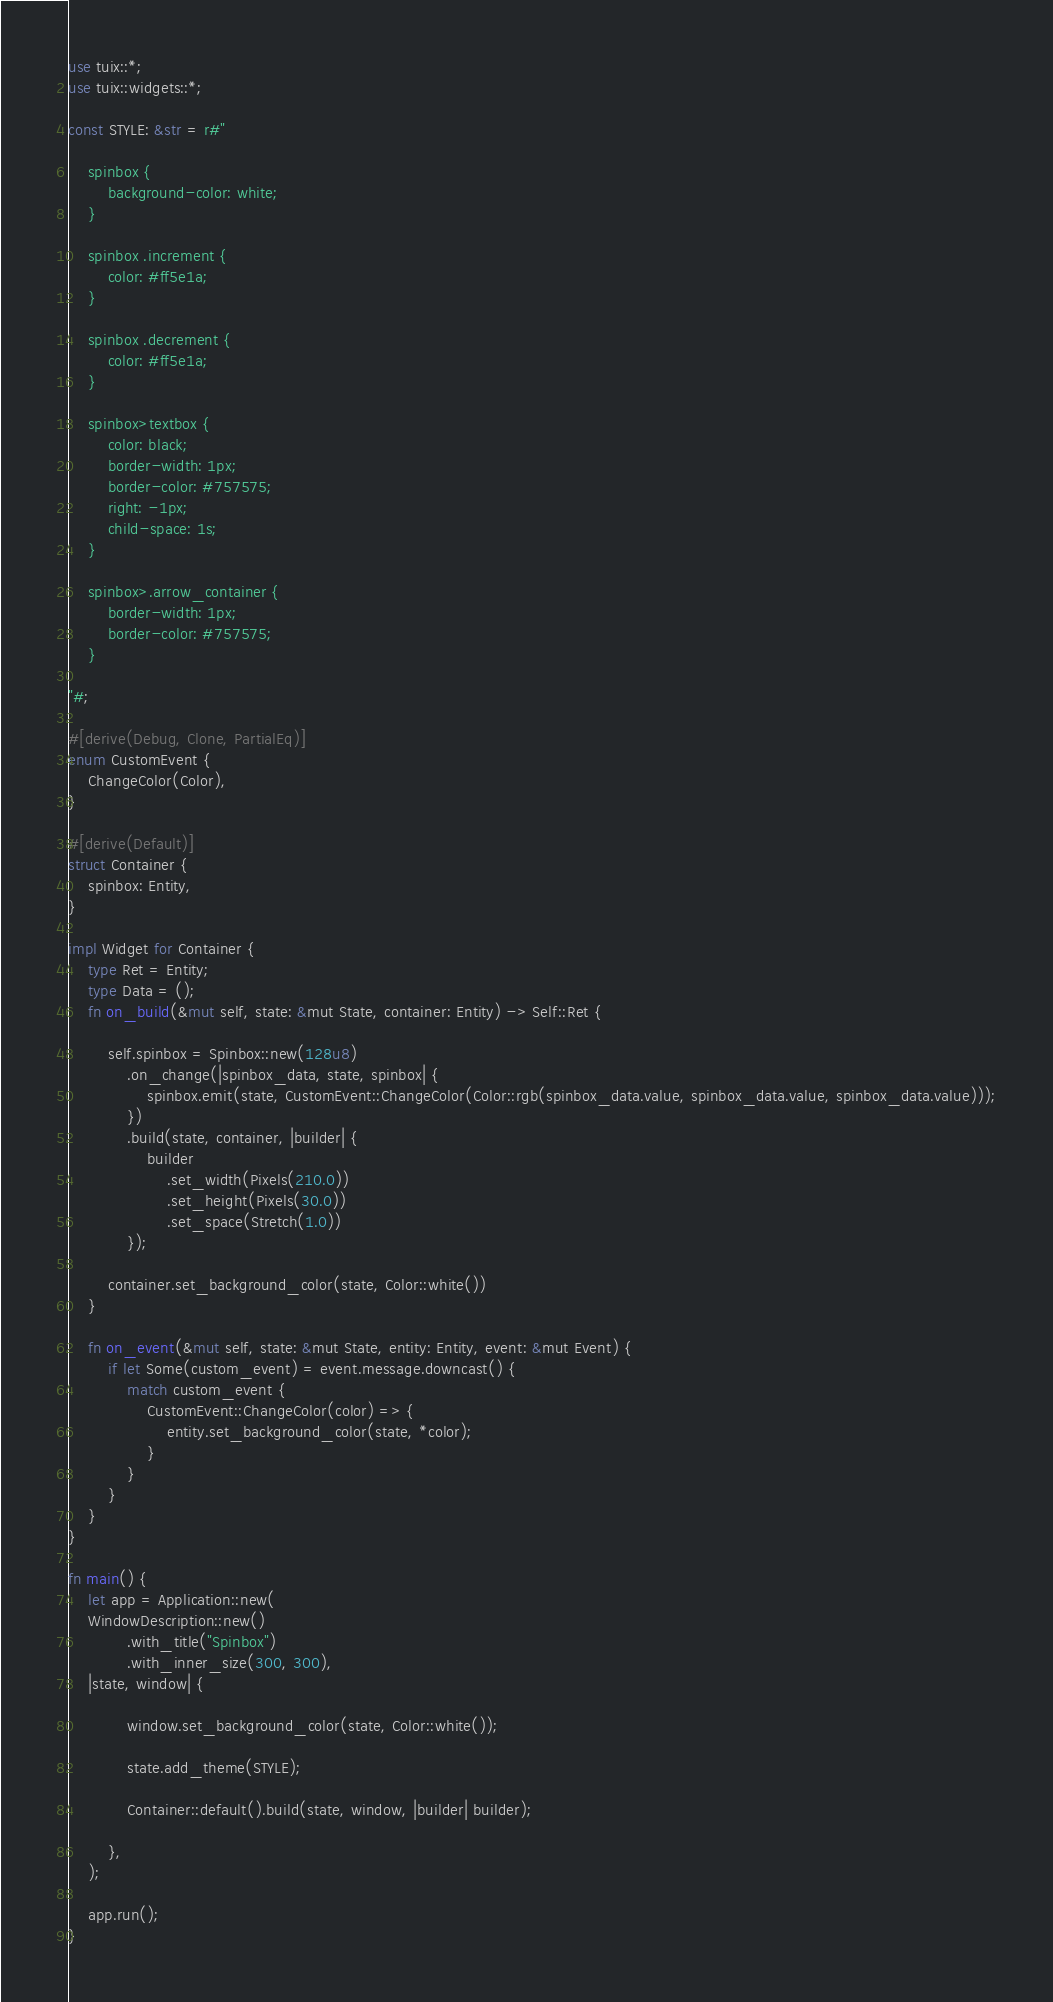<code> <loc_0><loc_0><loc_500><loc_500><_Rust_>use tuix::*;
use tuix::widgets::*;

const STYLE: &str = r#"

    spinbox {
        background-color: white;
    }

    spinbox .increment {
        color: #ff5e1a;
    }

    spinbox .decrement {
        color: #ff5e1a;
    }

    spinbox>textbox {
        color: black;
        border-width: 1px;
        border-color: #757575;
        right: -1px;
        child-space: 1s;
    }

    spinbox>.arrow_container {
        border-width: 1px;
        border-color: #757575;
    }

"#;

#[derive(Debug, Clone, PartialEq)]
enum CustomEvent {
    ChangeColor(Color),
}

#[derive(Default)]
struct Container {
    spinbox: Entity,
}

impl Widget for Container {
    type Ret = Entity;
    type Data = ();
    fn on_build(&mut self, state: &mut State, container: Entity) -> Self::Ret {

        self.spinbox = Spinbox::new(128u8)
            .on_change(|spinbox_data, state, spinbox| {
                spinbox.emit(state, CustomEvent::ChangeColor(Color::rgb(spinbox_data.value, spinbox_data.value, spinbox_data.value)));
            })
            .build(state, container, |builder| {
                builder
                    .set_width(Pixels(210.0))
                    .set_height(Pixels(30.0))
                    .set_space(Stretch(1.0))
            });

        container.set_background_color(state, Color::white())
    }

    fn on_event(&mut self, state: &mut State, entity: Entity, event: &mut Event) {
        if let Some(custom_event) = event.message.downcast() {
            match custom_event {
                CustomEvent::ChangeColor(color) => {
                    entity.set_background_color(state, *color);
                }
            }
        }
    }
}

fn main() {
    let app = Application::new(
    WindowDescription::new()
            .with_title("Spinbox")
            .with_inner_size(300, 300),
    |state, window| {

            window.set_background_color(state, Color::white());

            state.add_theme(STYLE);
            
            Container::default().build(state, window, |builder| builder);

        },
    );

    app.run();
}</code> 